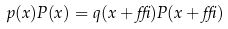Convert formula to latex. <formula><loc_0><loc_0><loc_500><loc_500>p ( x ) P ( x ) = q ( x + \delta ) P ( x + \delta )</formula> 